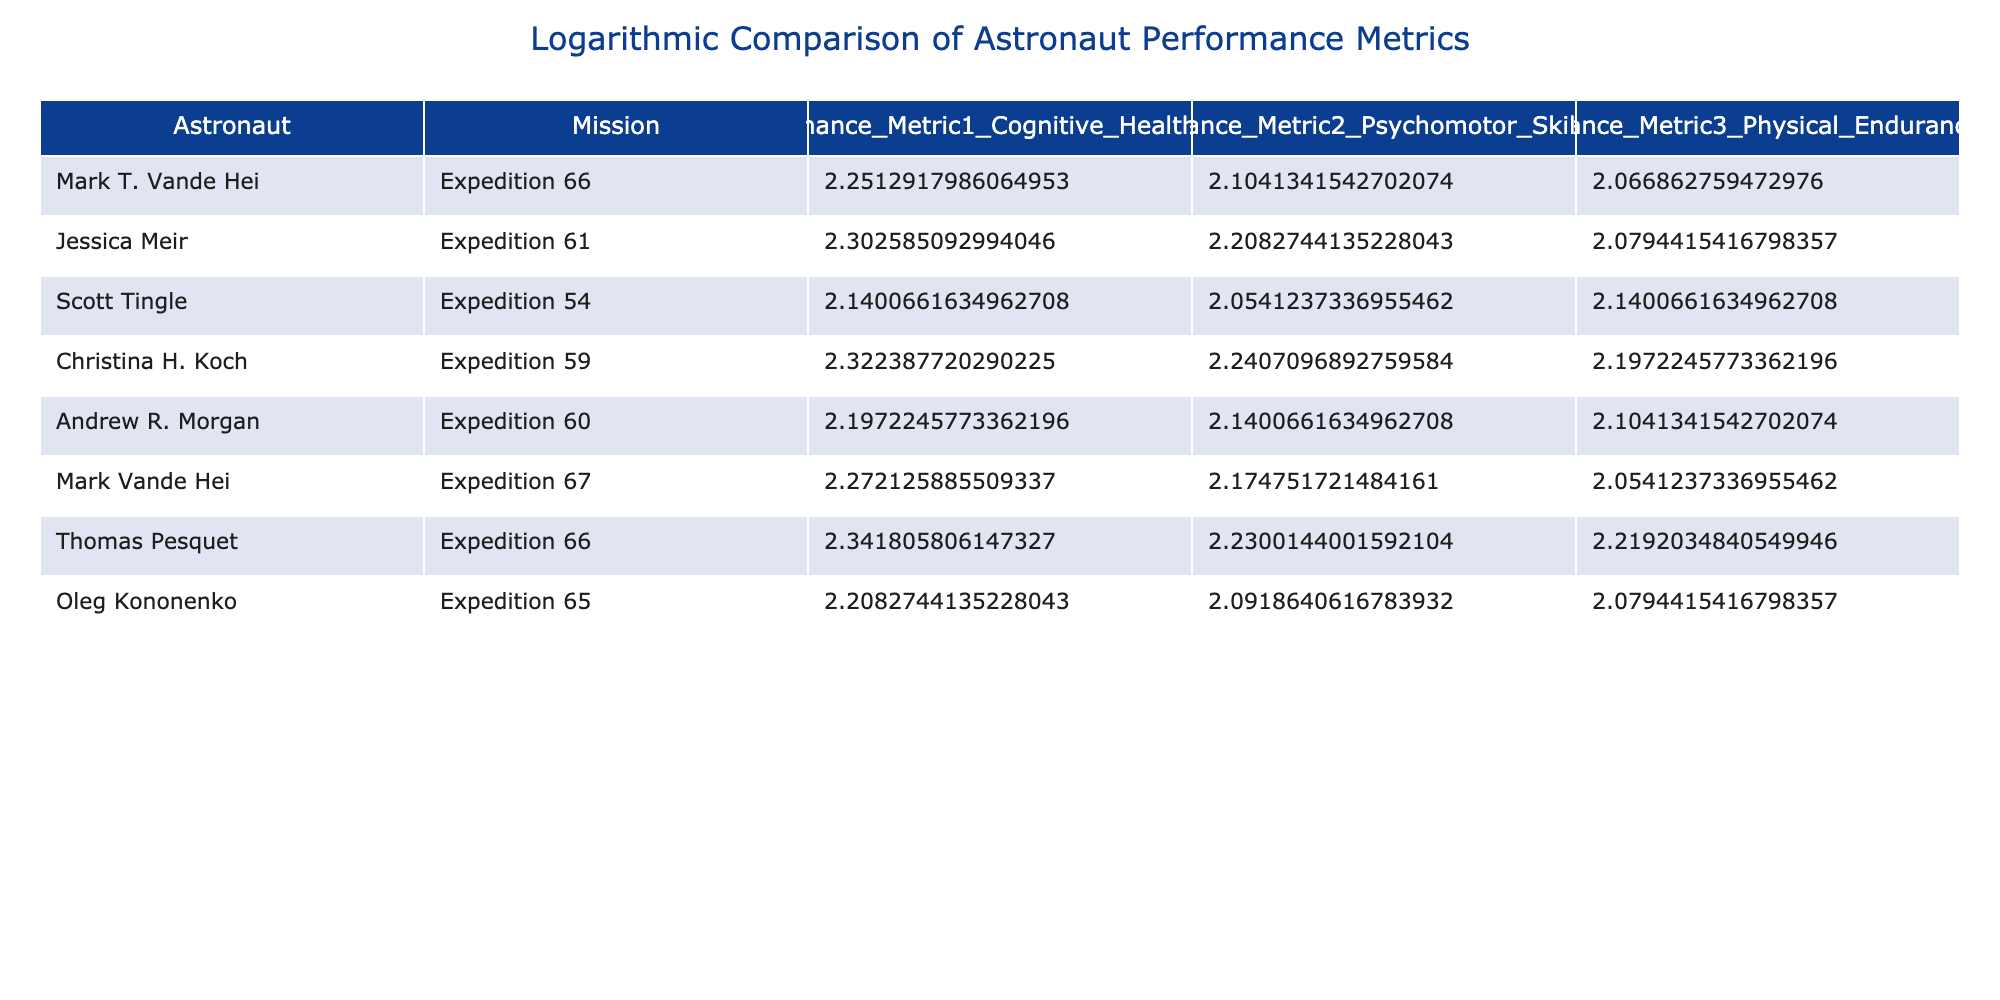What is the Cognitive Health Score of Christina H. Koch? In the table, locate the row for Christina H. Koch and read the value in the Cognitive Health Score column, which is 9.2
Answer: 9.2 Which astronaut has the highest Physical Endurance Score? To find this, compare the Physical Endurance Scores across all astronauts. The maximum value in the Physical Endurance Score column belongs to Scott Tingle with a score of 7.5.
Answer: Scott Tingle What is the average Psychomotor Skills Score of all astronauts? To calculate the average, sum all the Psychomotor Skills Scores (7.2 + 8.1 + 6.8 + 8.4 + 7.5 + 7.8 + 8.3 + 7.1 = 63.2) and then divide by the total number of astronauts (8). This gives an average of 63.2 / 8 = 7.9
Answer: 7.9 Is Oleg Kononenko's Cognitive Health Score greater than 8.0? Check the Cognitive Health Score for Oleg Kononenko, which is 8.1. Since 8.1 is greater than 8.0, the statement is true.
Answer: Yes What is the difference in Cognitive Health Scores between the astronauts with the highest and lowest scores? Identify the highest score (9.4 by Thomas Pesquet) and the lowest score (7.5 by Scott Tingle). The difference is calculated as 9.4 - 7.5 = 1.9
Answer: 1.9 Which mission did Andrew R. Morgan participate in? Look at the row corresponding to Andrew R. Morgan and check the Mission column, which shows he participated in Expedition 60.
Answer: Expedition 60 How many astronauts scored above 8.0 in the Physical Endurance Score? Count the scores in the Physical Endurance Score column and identify those greater than 8.0. In the table, there are no scores above 8.0, so the count is zero.
Answer: 0 What is the median of the Performance Metric 1 Cognitive Health Scores? First, list the Cognitive Health Scores: 8.5, 9.0, 7.5, 9.2, 8.0, 8.7, 9.4, 8.1. When sorted, the values are 7.5, 8.0, 8.1, 8.5, 8.7, 9.0, 9.2, 9.4. With 8 scores, the median is the average of the 4th (8.5) and 5th (8.7) values, (8.5 + 8.7) / 2 = 8.6
Answer: 8.6 